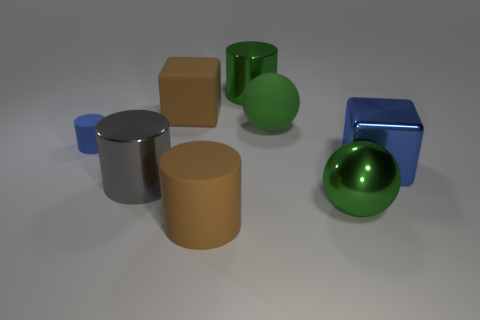What is the size of the brown object that is behind the big rubber cylinder?
Offer a terse response. Large. Is there any other thing that is the same material as the small blue object?
Offer a very short reply. Yes. How many small gray cylinders are there?
Your response must be concise. 0. Does the metal sphere have the same color as the large matte ball?
Provide a short and direct response. Yes. There is a big metallic object that is on the right side of the brown rubber cube and left of the big green shiny ball; what is its color?
Offer a terse response. Green. There is a big brown rubber cube; are there any large brown rubber cubes on the right side of it?
Offer a very short reply. No. How many rubber balls are in front of the large cylinder behind the large brown matte block?
Offer a terse response. 1. The gray cylinder that is the same material as the blue cube is what size?
Give a very brief answer. Large. What is the size of the metallic sphere?
Ensure brevity in your answer.  Large. Is the brown cylinder made of the same material as the large brown block?
Offer a terse response. Yes. 